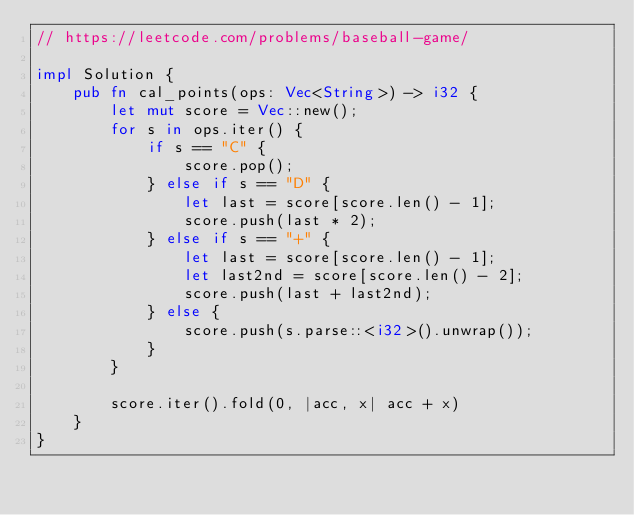<code> <loc_0><loc_0><loc_500><loc_500><_Rust_>// https://leetcode.com/problems/baseball-game/

impl Solution {
    pub fn cal_points(ops: Vec<String>) -> i32 {
        let mut score = Vec::new();
        for s in ops.iter() {
            if s == "C" {
                score.pop();
            } else if s == "D" {
                let last = score[score.len() - 1];
                score.push(last * 2);
            } else if s == "+" {
                let last = score[score.len() - 1];
                let last2nd = score[score.len() - 2];
                score.push(last + last2nd);
            } else {
                score.push(s.parse::<i32>().unwrap());
            }
        }

        score.iter().fold(0, |acc, x| acc + x)
    }
}
</code> 